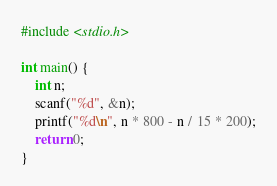<code> <loc_0><loc_0><loc_500><loc_500><_C_>#include <stdio.h>

int main() {
	int n;
	scanf("%d", &n);
	printf("%d\n", n * 800 - n / 15 * 200);
	return 0;
}</code> 